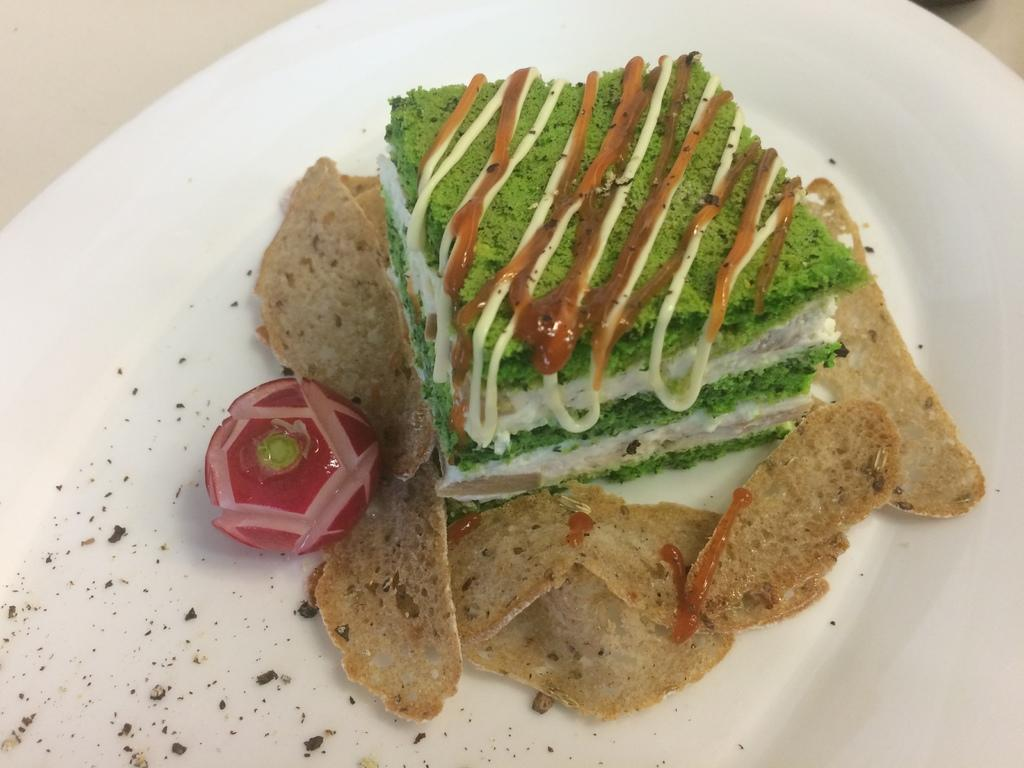What is on the plate that is visible in the image? There is food on a plate in the image. Where is the plate located in the image? The plate is placed on a white surface. What type of thread is being used to drive the food on the plate in the image? There is no thread or driving involved in the image; the food is simply placed on the plate. 